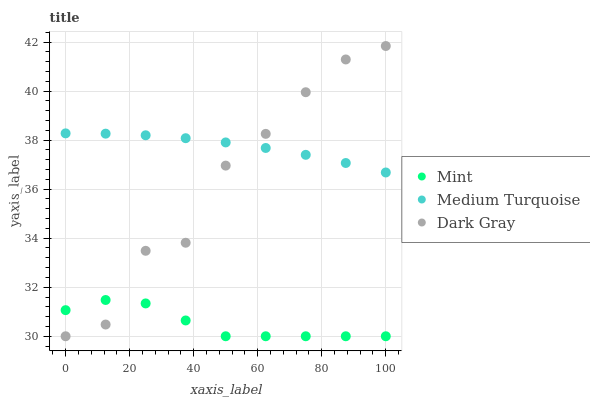Does Mint have the minimum area under the curve?
Answer yes or no. Yes. Does Medium Turquoise have the maximum area under the curve?
Answer yes or no. Yes. Does Medium Turquoise have the minimum area under the curve?
Answer yes or no. No. Does Mint have the maximum area under the curve?
Answer yes or no. No. Is Medium Turquoise the smoothest?
Answer yes or no. Yes. Is Dark Gray the roughest?
Answer yes or no. Yes. Is Mint the smoothest?
Answer yes or no. No. Is Mint the roughest?
Answer yes or no. No. Does Dark Gray have the lowest value?
Answer yes or no. Yes. Does Medium Turquoise have the lowest value?
Answer yes or no. No. Does Dark Gray have the highest value?
Answer yes or no. Yes. Does Medium Turquoise have the highest value?
Answer yes or no. No. Is Mint less than Medium Turquoise?
Answer yes or no. Yes. Is Medium Turquoise greater than Mint?
Answer yes or no. Yes. Does Medium Turquoise intersect Dark Gray?
Answer yes or no. Yes. Is Medium Turquoise less than Dark Gray?
Answer yes or no. No. Is Medium Turquoise greater than Dark Gray?
Answer yes or no. No. Does Mint intersect Medium Turquoise?
Answer yes or no. No. 